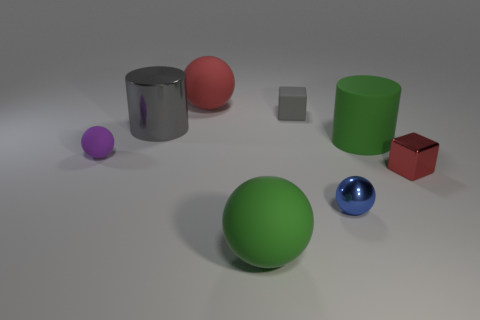Add 1 big red things. How many objects exist? 9 Subtract all red balls. How many balls are left? 3 Subtract all gray cylinders. How many cylinders are left? 1 Subtract all blocks. How many objects are left? 6 Subtract all brown spheres. Subtract all red blocks. How many spheres are left? 4 Add 4 large matte cylinders. How many large matte cylinders exist? 5 Subtract 1 gray blocks. How many objects are left? 7 Subtract 2 cubes. How many cubes are left? 0 Subtract all yellow cubes. How many red spheres are left? 1 Subtract all matte spheres. Subtract all large red balls. How many objects are left? 4 